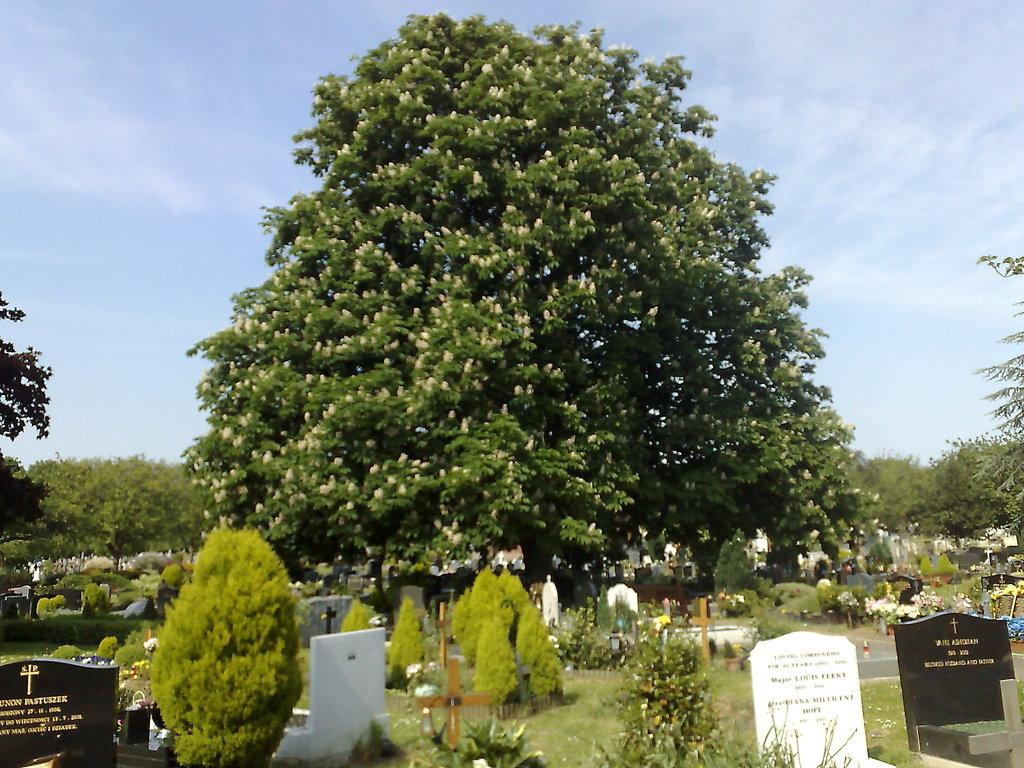What is located at the bottom of the image? There is a graveyard at the bottom of the image. What can be seen in the middle of the image? There is a big tree in the middle of the image. What is visible at the top of the image? The sky is visible at the top of the image. How many crows are sitting on the big tree in the image? There is no mention of crows in the image; it only features a graveyard, a big tree, and the sky. What type of ear is visible on the tree in the image? There is no ear present in the image; it only features a graveyard, a big tree, and the sky. 